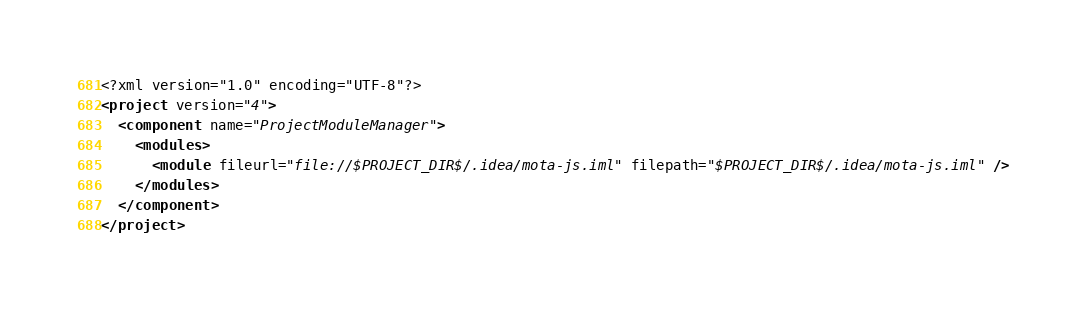Convert code to text. <code><loc_0><loc_0><loc_500><loc_500><_XML_><?xml version="1.0" encoding="UTF-8"?>
<project version="4">
  <component name="ProjectModuleManager">
    <modules>
      <module fileurl="file://$PROJECT_DIR$/.idea/mota-js.iml" filepath="$PROJECT_DIR$/.idea/mota-js.iml" />
    </modules>
  </component>
</project></code> 